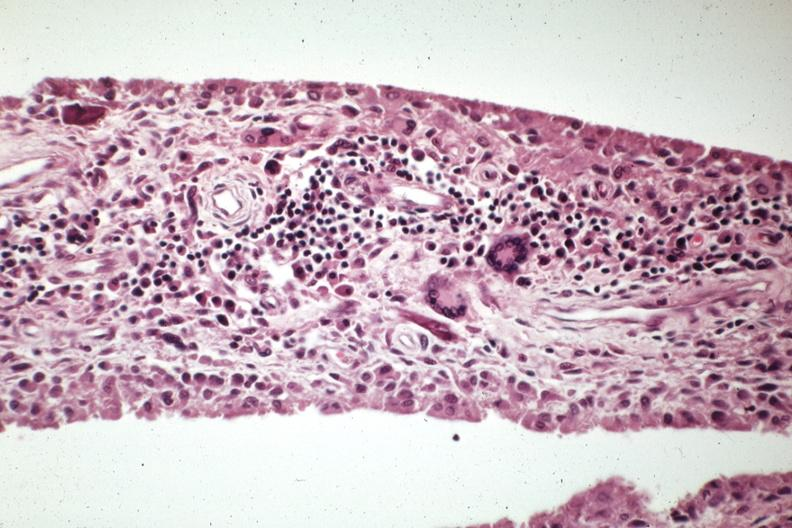what does this image show?
Answer the question using a single word or phrase. Chronic inflammatory cells and langhans type giant cells case 31 